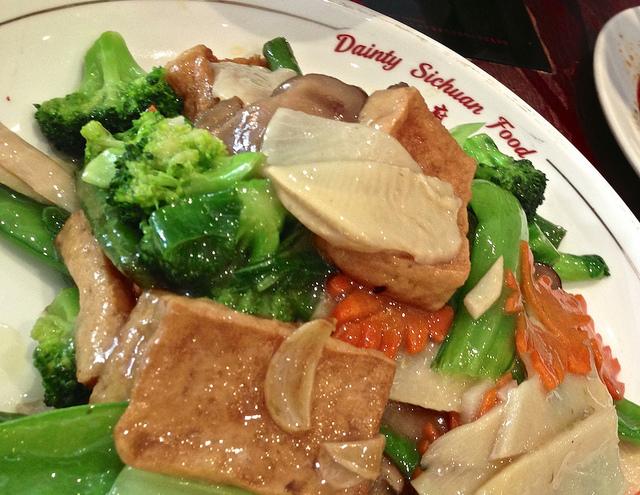What is the name of the establishment?
Keep it brief. Dainty sichuan food. Is this Asian food?
Keep it brief. Yes. Is this dish spicy?
Write a very short answer. No. 